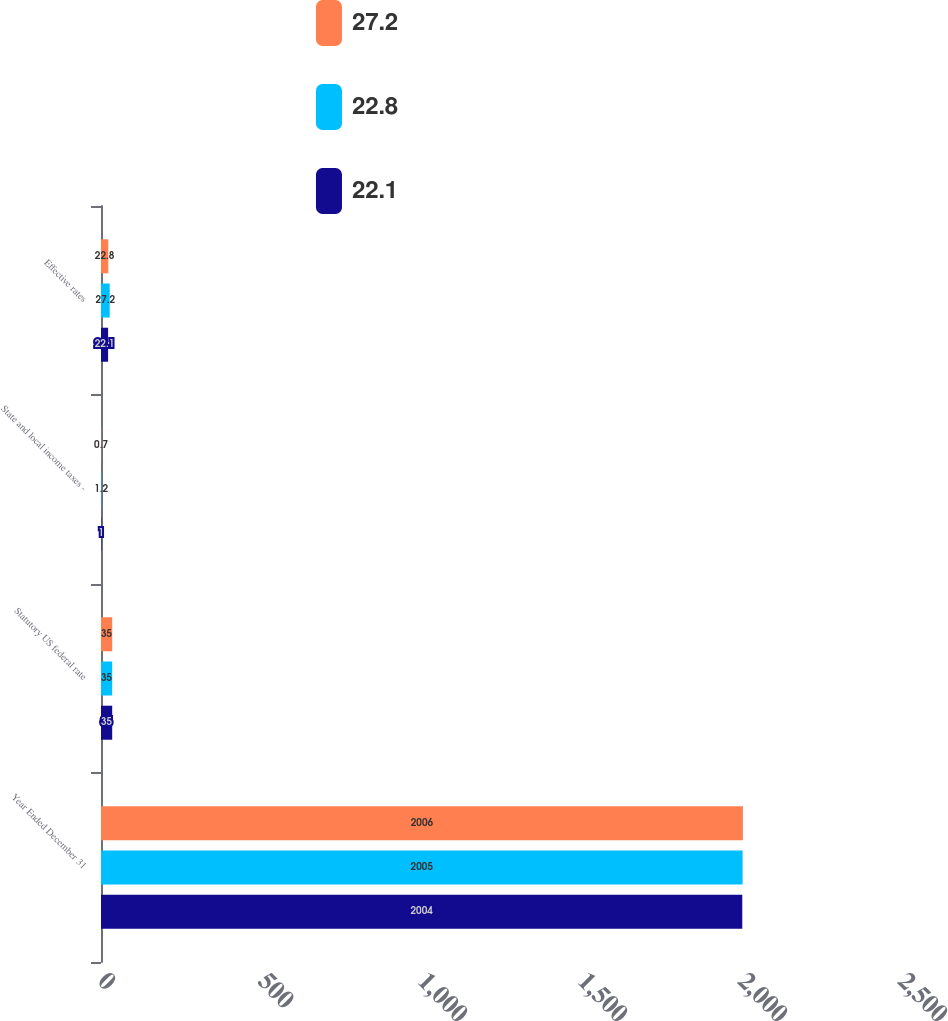<chart> <loc_0><loc_0><loc_500><loc_500><stacked_bar_chart><ecel><fcel>Year Ended December 31<fcel>Statutory US federal rate<fcel>State and local income taxes -<fcel>Effective rates<nl><fcel>27.2<fcel>2006<fcel>35<fcel>0.7<fcel>22.8<nl><fcel>22.8<fcel>2005<fcel>35<fcel>1.2<fcel>27.2<nl><fcel>22.1<fcel>2004<fcel>35<fcel>1<fcel>22.1<nl></chart> 